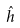<formula> <loc_0><loc_0><loc_500><loc_500>\hat { h }</formula> 